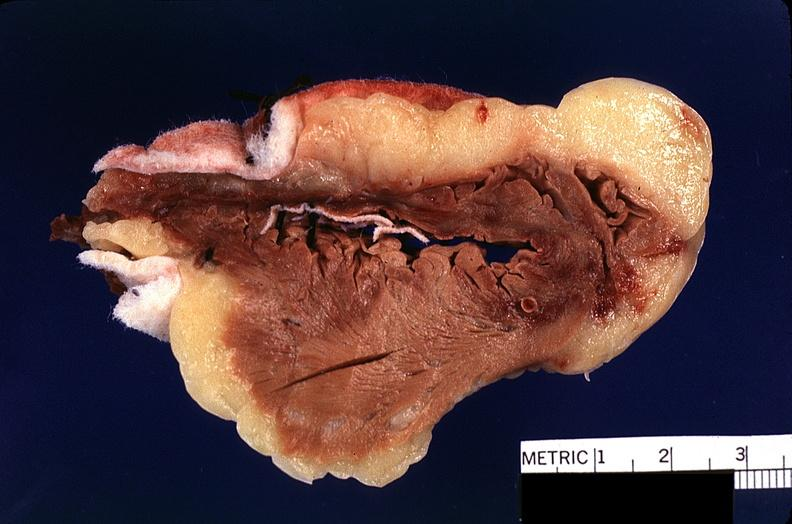s myocardium present?
Answer the question using a single word or phrase. No 